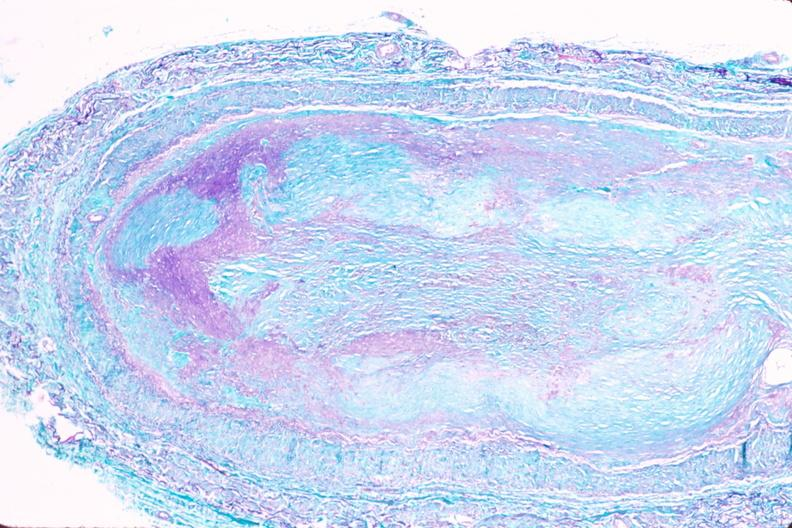s cardiovascular present?
Answer the question using a single word or phrase. Yes 